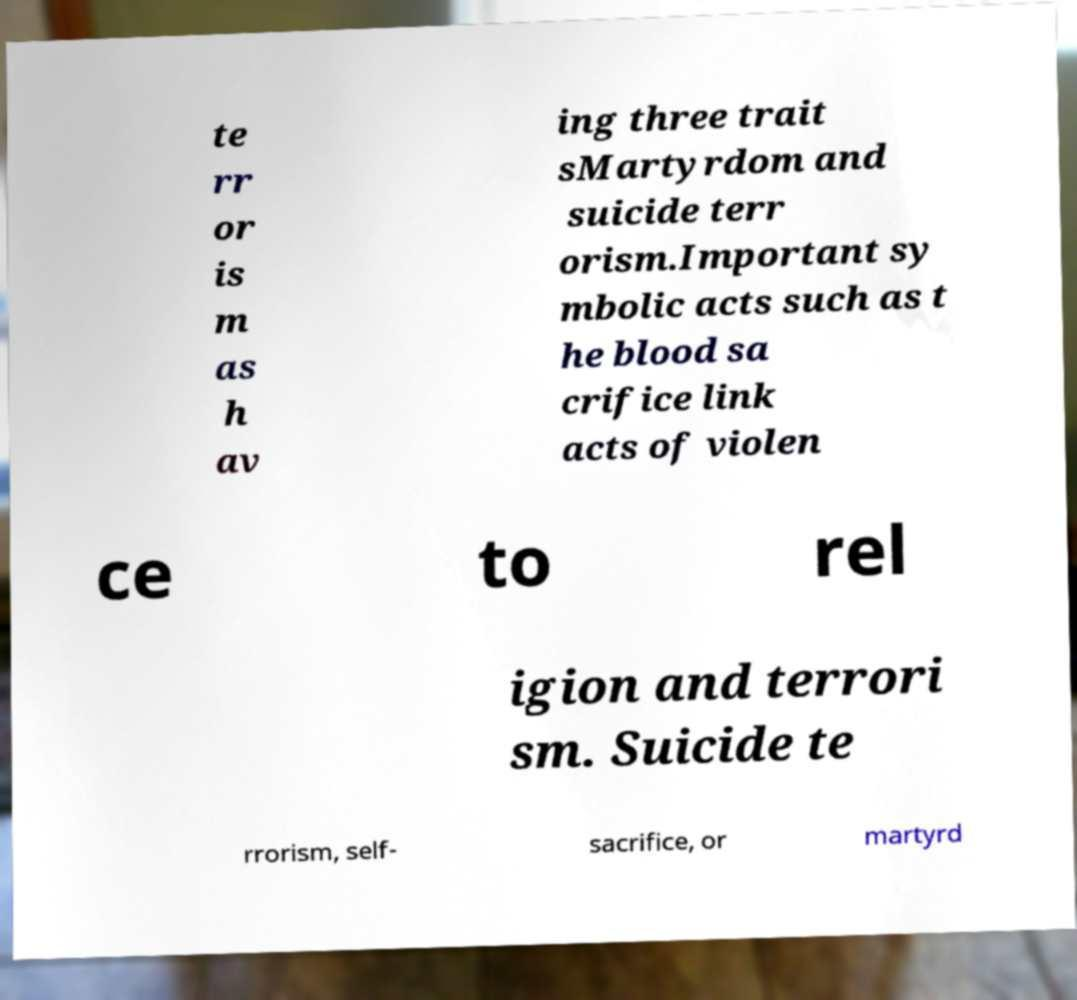What messages or text are displayed in this image? I need them in a readable, typed format. te rr or is m as h av ing three trait sMartyrdom and suicide terr orism.Important sy mbolic acts such as t he blood sa crifice link acts of violen ce to rel igion and terrori sm. Suicide te rrorism, self- sacrifice, or martyrd 